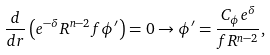Convert formula to latex. <formula><loc_0><loc_0><loc_500><loc_500>\frac { d } { d r } \left ( e ^ { - \delta } R ^ { n - 2 } f \phi ^ { \prime } \right ) = 0 \to \phi ^ { \prime } = \frac { C _ { \phi } e ^ { \delta } } { f R ^ { n - 2 } } ,</formula> 